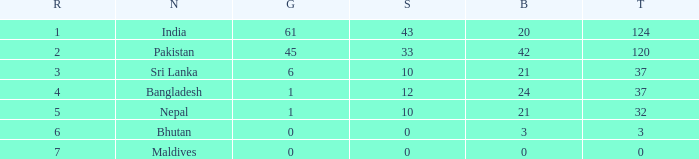Which Gold has a Rank smaller than 5, and a Bronze of 20? 61.0. 